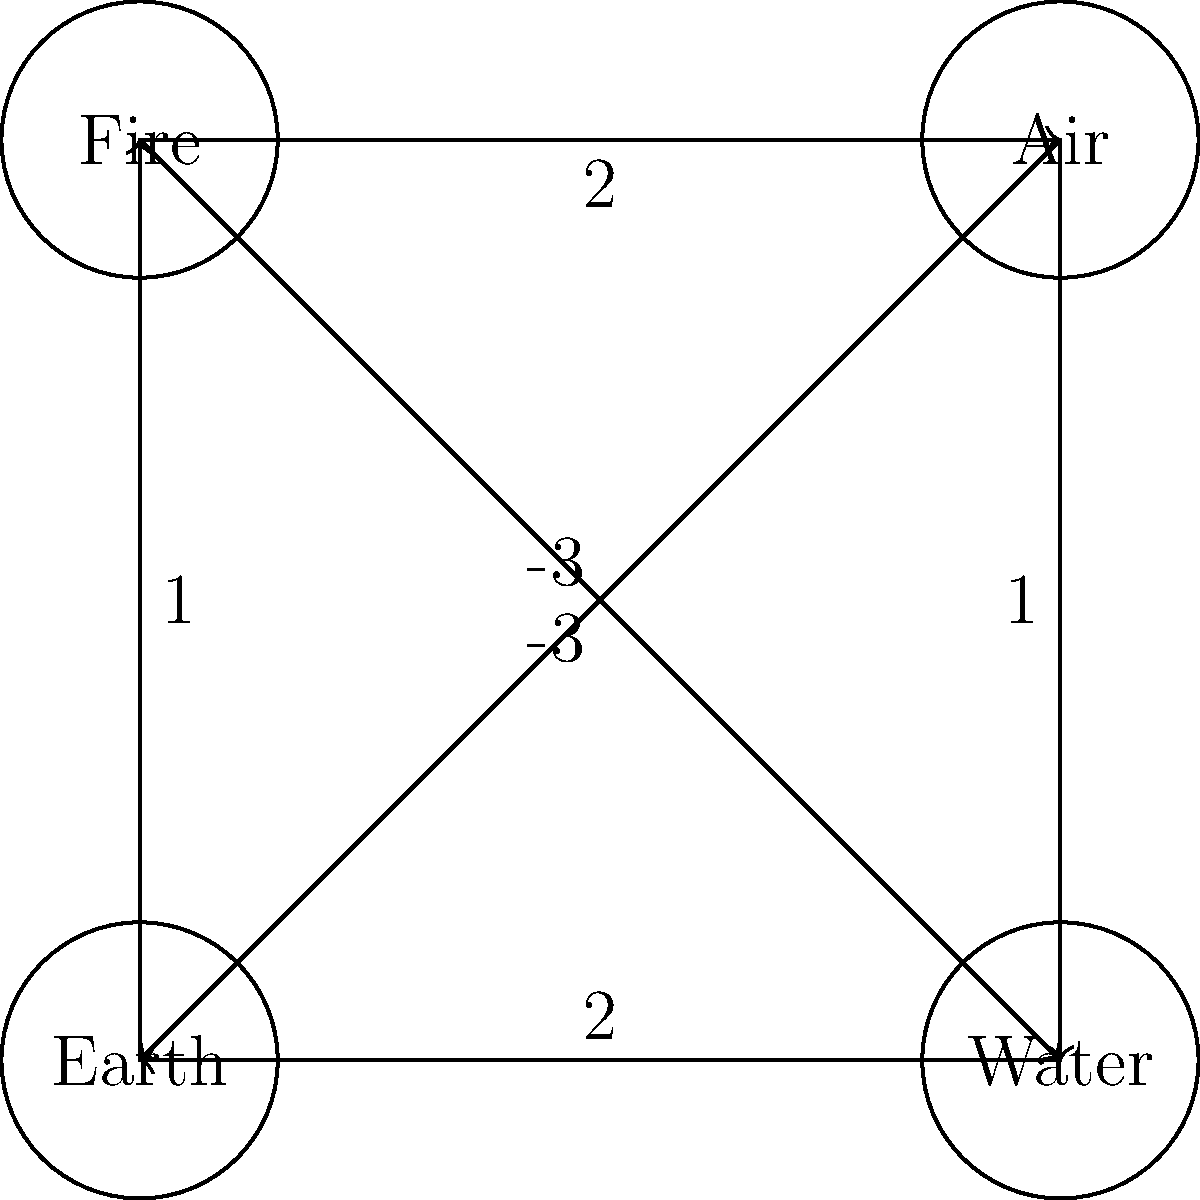In the elemental affinity graph shown, each node represents an element, and the directed edges with weights represent the strength and nature of their relationships. Positive weights indicate harmony, while negative weights indicate opposition. What is the total weight of the shortest path from Fire to Water that passes through exactly three edges? To solve this problem, we need to consider all possible paths from Fire to Water that use exactly three edges. Let's break it down step-by-step:

1. Identify possible paths:
   a) Fire → Air → Water
   b) Fire → Air → Earth → Water
   c) Fire → Earth → Air → Water
   d) Fire → Earth → Fire → Air → Water (invalid, as it uses 4 edges)

2. Calculate the weight of each valid path:
   a) Fire → Air → Water:
      Weight = 2 + 1 = 3

   b) Fire → Air → Earth → Water:
      Weight = 2 + (-3) + 2 = 1

   c) Fire → Earth → Air → Water:
      Weight = 1 + (-3) + 1 = -1

3. Compare the weights:
   Path (a): 3
   Path (b): 1
   Path (c): -1

4. Identify the shortest path:
   The shortest path is the one with the lowest absolute weight, which is path (c) with a weight of -1.

Therefore, the total weight of the shortest path from Fire to Water that passes through exactly three edges is -1.
Answer: -1 